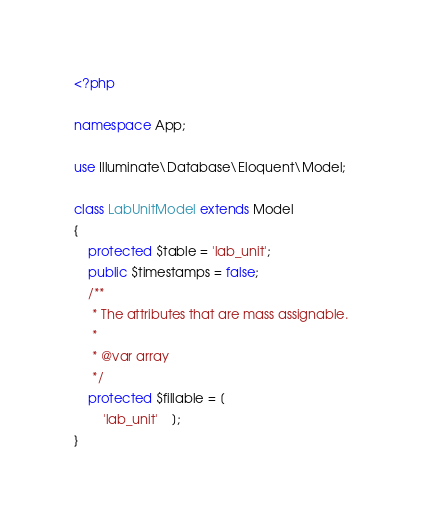Convert code to text. <code><loc_0><loc_0><loc_500><loc_500><_PHP_><?php

namespace App;

use Illuminate\Database\Eloquent\Model;

class LabUnitModel extends Model
{
    protected $table = 'lab_unit';
	public $timestamps = false;
	/**
	 * The attributes that are mass assignable.
	 *
	 * @var array
	 */
	protected $fillable = [
		'lab_unit'	];
}
</code> 